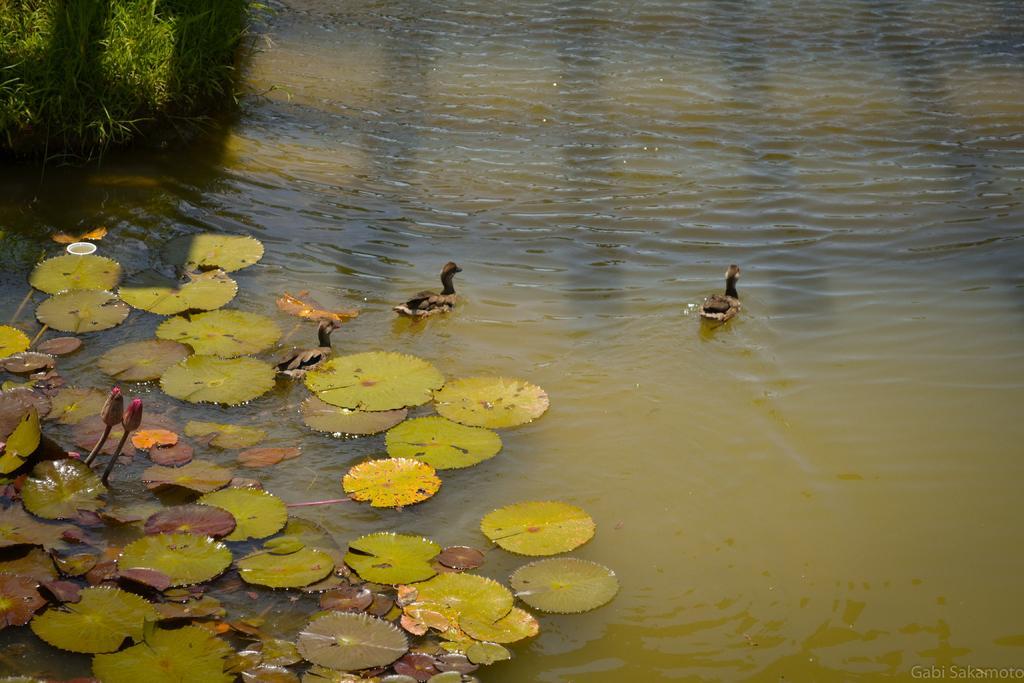In one or two sentences, can you explain what this image depicts? In this picture I can see ducks in the water, there are leaves and flower buds on the water, there is grass, and there is a watermark on the image. 